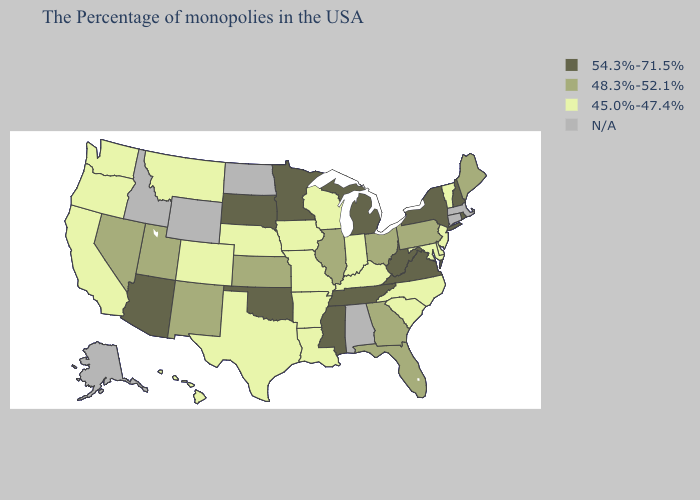What is the lowest value in the South?
Short answer required. 45.0%-47.4%. What is the highest value in the South ?
Answer briefly. 54.3%-71.5%. What is the value of Massachusetts?
Give a very brief answer. N/A. Is the legend a continuous bar?
Keep it brief. No. What is the value of New Mexico?
Give a very brief answer. 48.3%-52.1%. Name the states that have a value in the range 45.0%-47.4%?
Answer briefly. Vermont, New Jersey, Delaware, Maryland, North Carolina, South Carolina, Kentucky, Indiana, Wisconsin, Louisiana, Missouri, Arkansas, Iowa, Nebraska, Texas, Colorado, Montana, California, Washington, Oregon, Hawaii. What is the value of South Carolina?
Short answer required. 45.0%-47.4%. What is the value of New Hampshire?
Short answer required. 54.3%-71.5%. Is the legend a continuous bar?
Answer briefly. No. Which states have the lowest value in the South?
Short answer required. Delaware, Maryland, North Carolina, South Carolina, Kentucky, Louisiana, Arkansas, Texas. Which states have the lowest value in the Northeast?
Write a very short answer. Vermont, New Jersey. Which states have the highest value in the USA?
Quick response, please. Rhode Island, New Hampshire, New York, Virginia, West Virginia, Michigan, Tennessee, Mississippi, Minnesota, Oklahoma, South Dakota, Arizona. What is the value of Arizona?
Short answer required. 54.3%-71.5%. What is the value of Delaware?
Keep it brief. 45.0%-47.4%. 